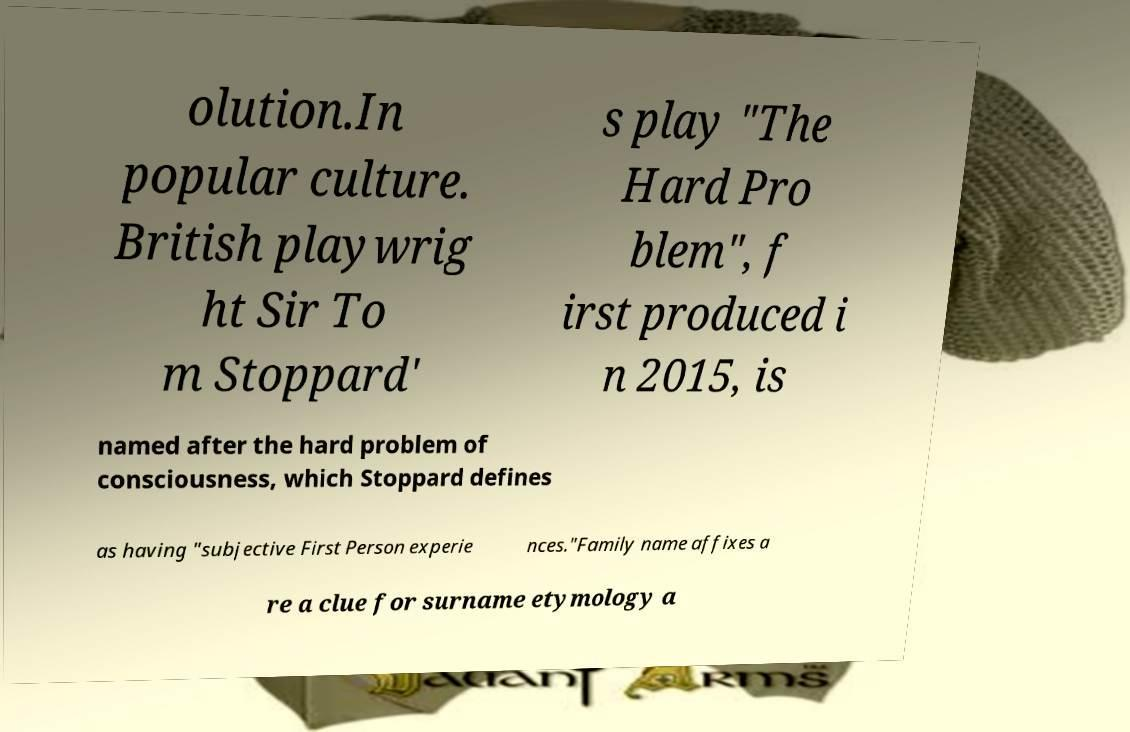I need the written content from this picture converted into text. Can you do that? olution.In popular culture. British playwrig ht Sir To m Stoppard' s play "The Hard Pro blem", f irst produced i n 2015, is named after the hard problem of consciousness, which Stoppard defines as having "subjective First Person experie nces."Family name affixes a re a clue for surname etymology a 